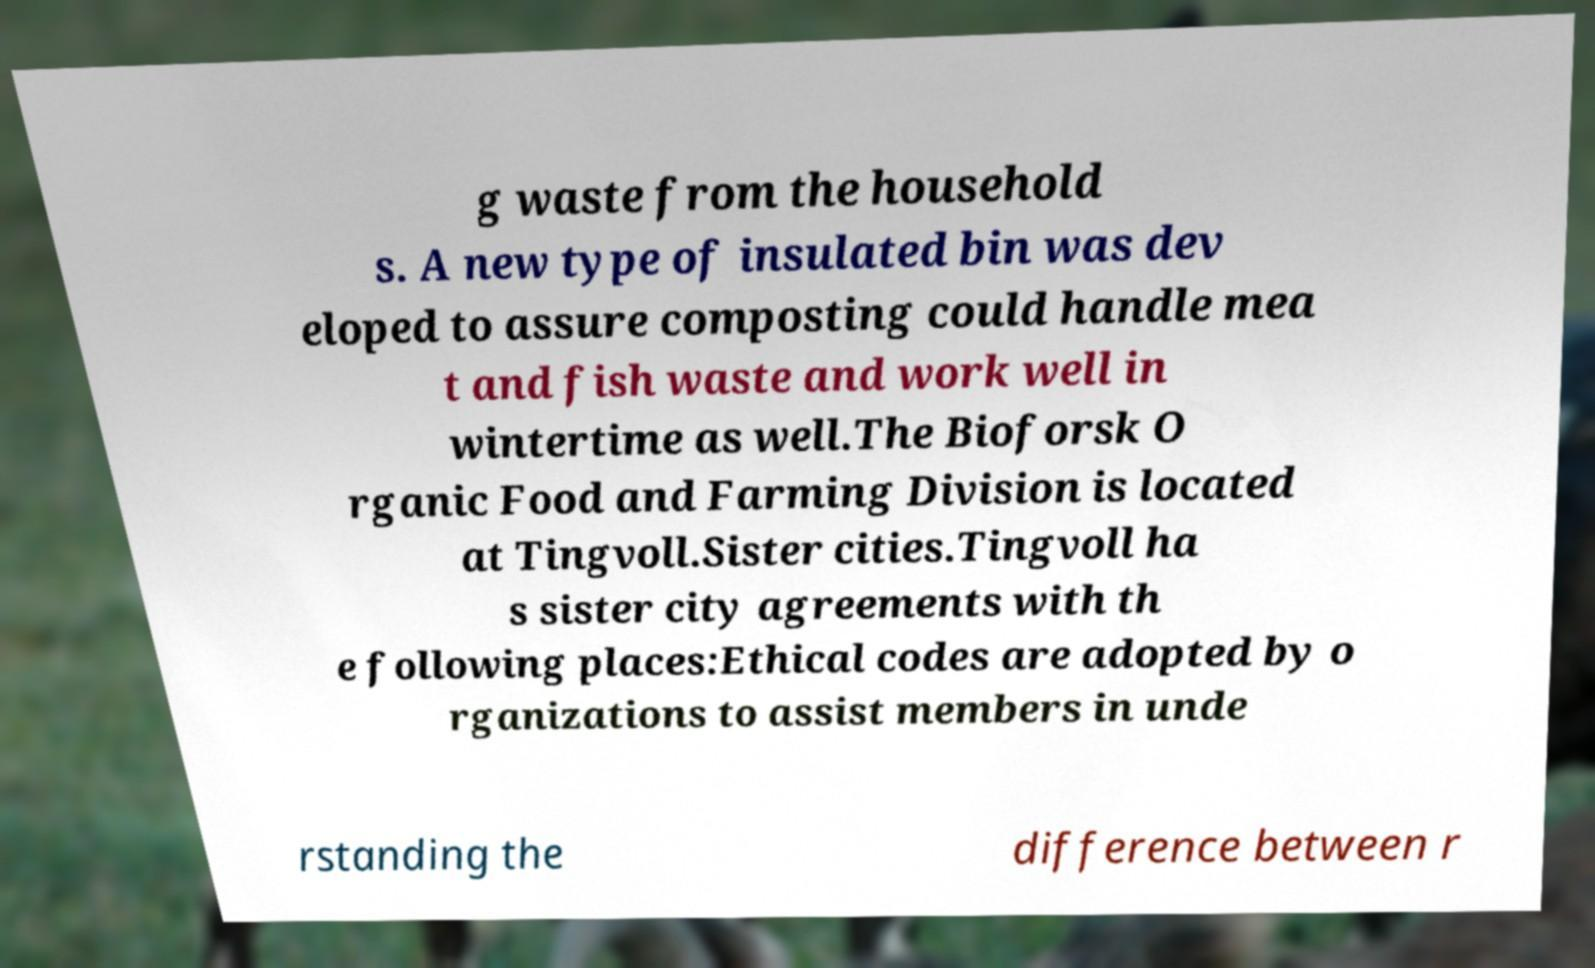Can you accurately transcribe the text from the provided image for me? g waste from the household s. A new type of insulated bin was dev eloped to assure composting could handle mea t and fish waste and work well in wintertime as well.The Bioforsk O rganic Food and Farming Division is located at Tingvoll.Sister cities.Tingvoll ha s sister city agreements with th e following places:Ethical codes are adopted by o rganizations to assist members in unde rstanding the difference between r 